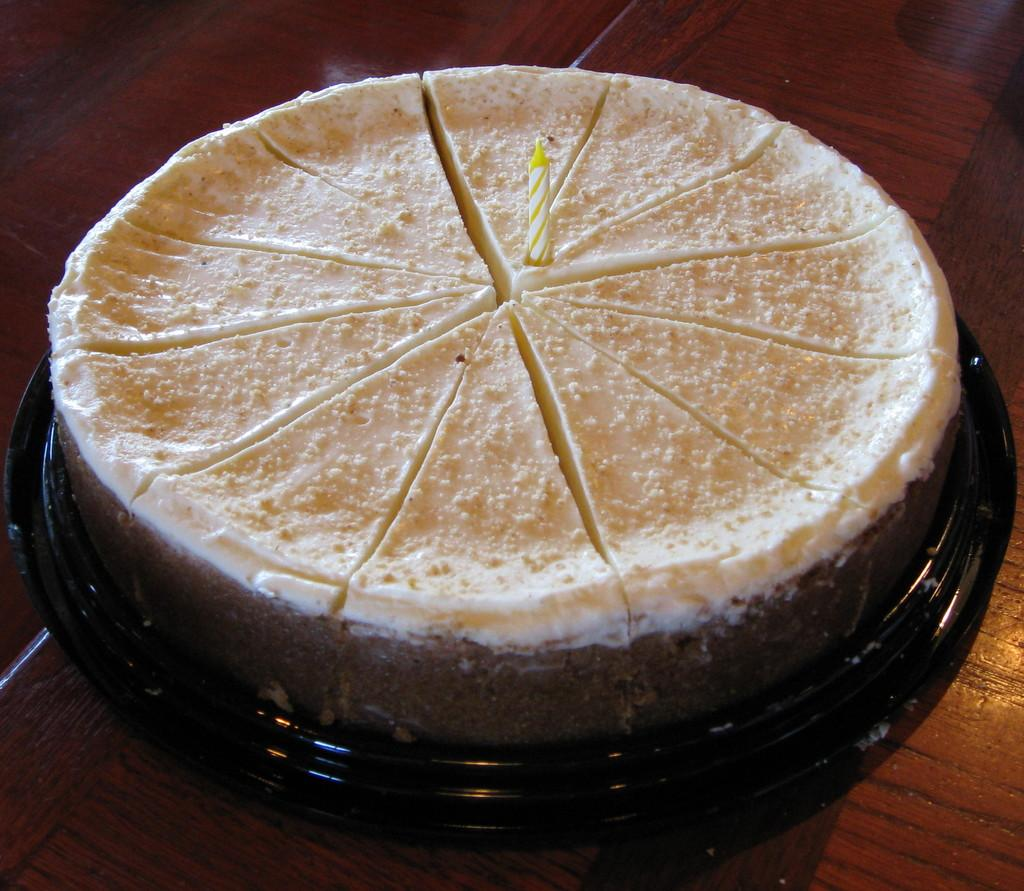What is the main piece of furniture in the image? There is a table in the image. What is placed on the table? There is a cake on the table. How is the cake positioned on the table? The cake is on a plate. What is added to the cake as a decoration? There is a candle on the cake. What type of noise can be heard coming from the bikes in the image? There are no bikes present in the image, so it's not possible to determine what, if any, noise might be heard. 